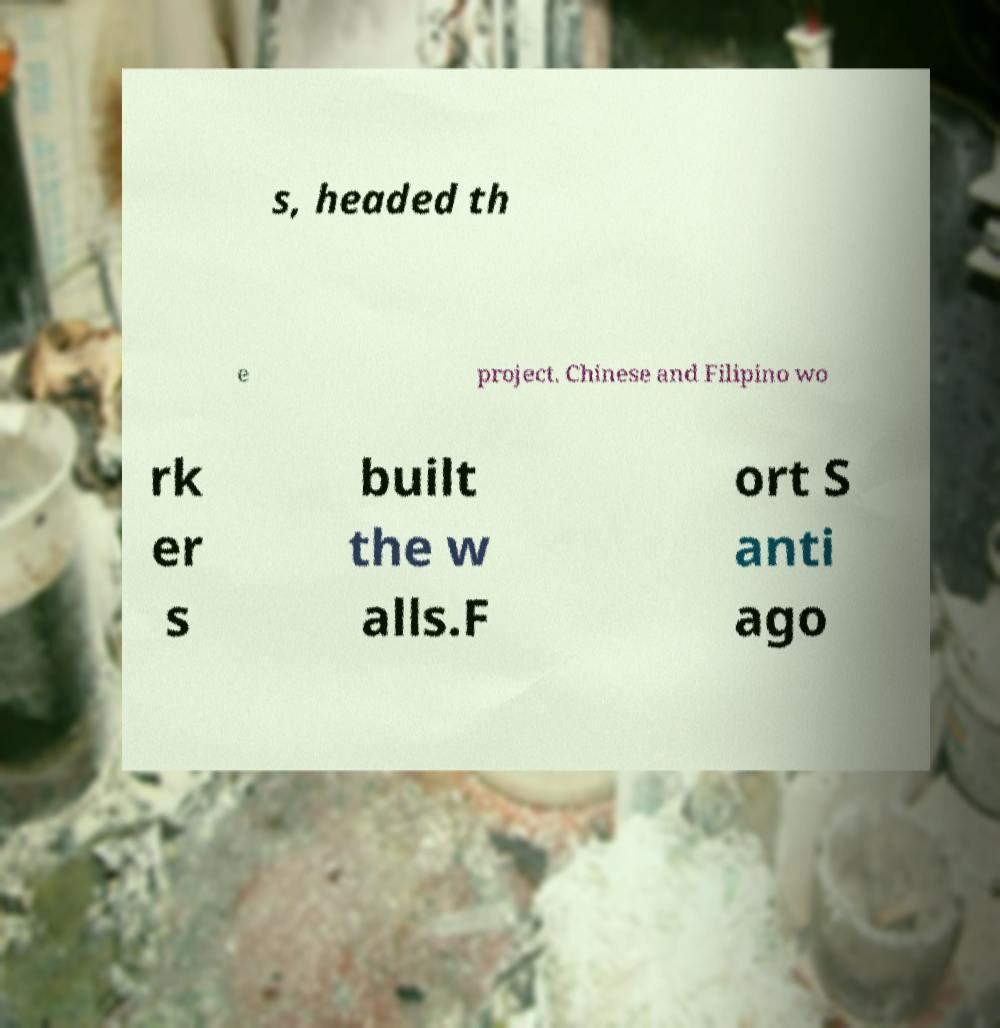Can you accurately transcribe the text from the provided image for me? s, headed th e project. Chinese and Filipino wo rk er s built the w alls.F ort S anti ago 